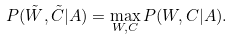<formula> <loc_0><loc_0><loc_500><loc_500>P ( { \tilde { W } } , { \tilde { C } } | { A } ) = \max _ { { W } , { C } } P ( { W } , { C } | { A } ) .</formula> 